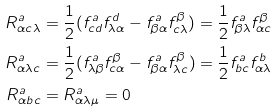Convert formula to latex. <formula><loc_0><loc_0><loc_500><loc_500>R _ { \alpha c \lambda } ^ { a } & = \frac { 1 } { 2 } ( f _ { c d } ^ { a } f _ { \lambda \alpha } ^ { d } - f _ { \beta \alpha } ^ { a } f _ { c \lambda } ^ { \beta } ) = \frac { 1 } { 2 } f _ { \beta \lambda } ^ { a } f _ { \alpha c } ^ { \beta } \\ R _ { \alpha \lambda c } ^ { a } & = \frac { 1 } { 2 } ( f _ { \lambda \beta } ^ { a } f _ { c \alpha } ^ { \beta } - f _ { \beta \alpha } ^ { a } f _ { \lambda c } ^ { \beta } ) = \frac { 1 } { 2 } f _ { b c } ^ { a } f _ { \alpha \lambda } ^ { b } \\ R _ { \alpha b c } ^ { a } & = R _ { \alpha \lambda \mu } ^ { a } = 0</formula> 